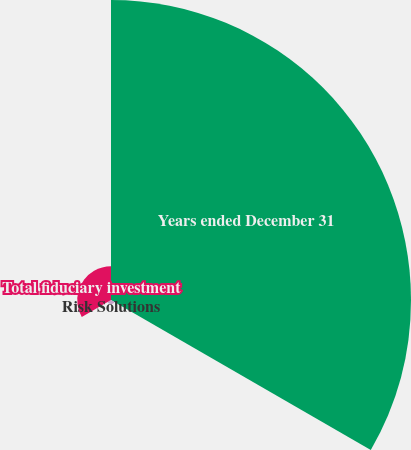Convert chart. <chart><loc_0><loc_0><loc_500><loc_500><pie_chart><fcel>Years ended December 31<fcel>Risk Solutions<fcel>Total fiduciary investment<nl><fcel>88.78%<fcel>1.23%<fcel>9.99%<nl></chart> 